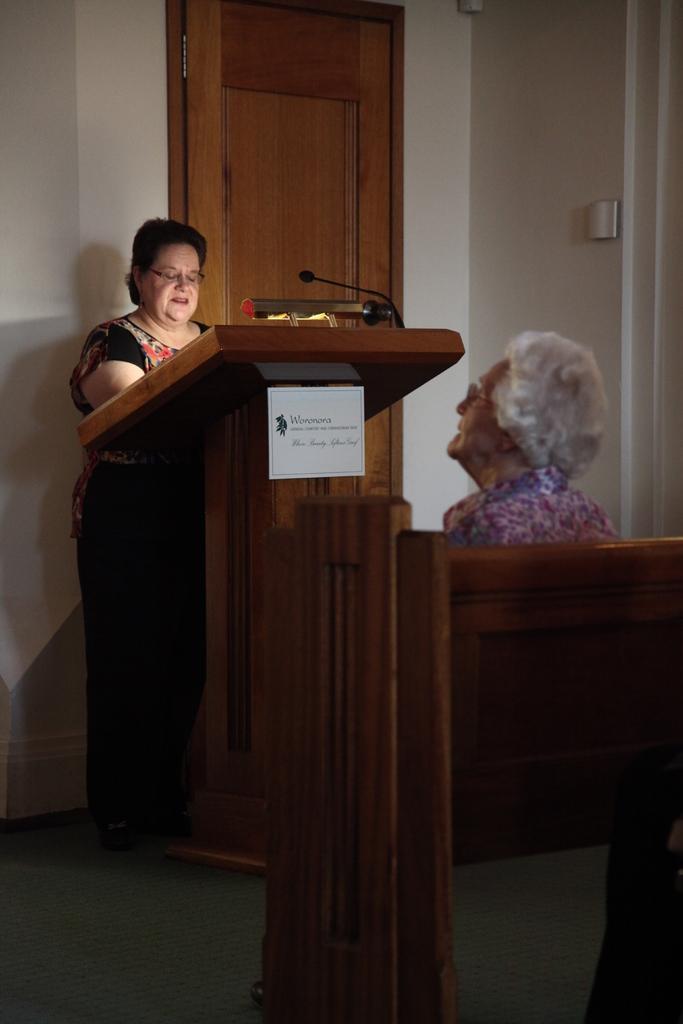Can you describe this image briefly? In this picture there is a woman standing in front of a wooden stand and there is a mic placed on it and there is another woman sitting in the right corner. 